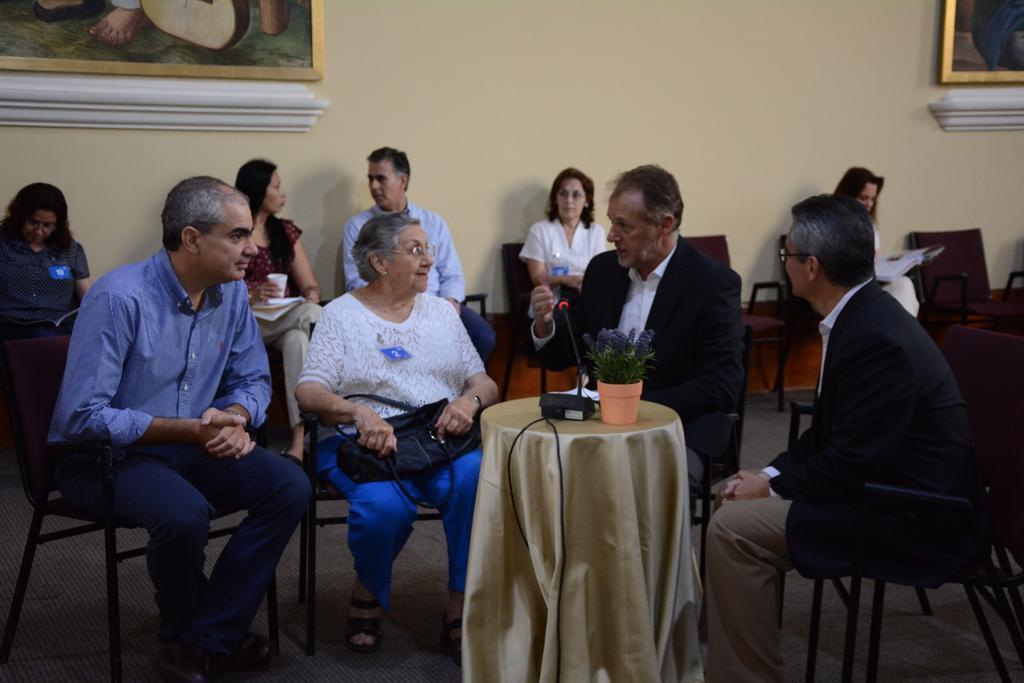Can you describe this image briefly? A group of four people are sitting around a table and talking among themselves. Of them three are men and one is woman. There is a mic and small plant on the stool. There few other people sitting in chairs in the background. There are two photo frames on the wall. 